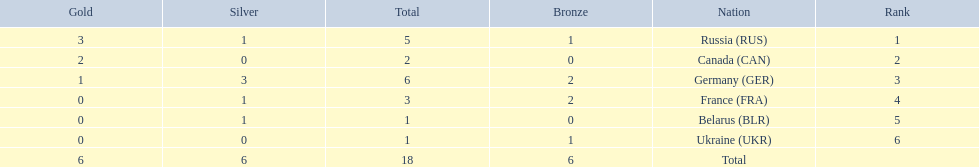What was the total number of silver medals awarded to the french and the germans in the 1994 winter olympic biathlon? 4. 